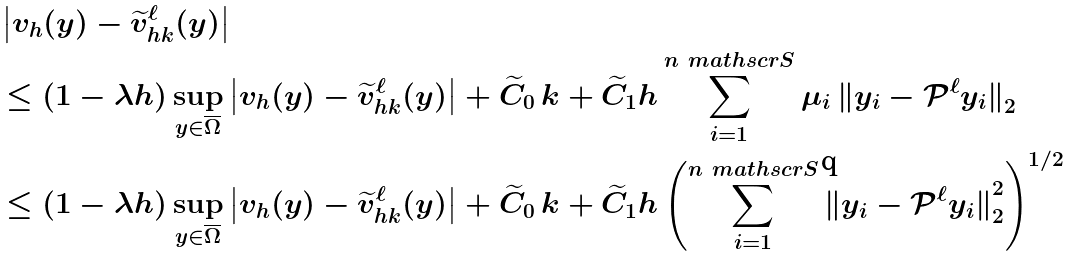Convert formula to latex. <formula><loc_0><loc_0><loc_500><loc_500>& \left | v _ { h } ( y ) - \widetilde { v } _ { h k } ^ { \ell } ( y ) \right | \\ & \leq ( 1 - \lambda h ) \sup _ { y \in \overline { \Omega } } \left | v _ { h } ( y ) - \widetilde { v } _ { h k } ^ { \ell } ( y ) \right | + \widetilde { C } _ { 0 } \, k + \widetilde { C } _ { 1 } h \sum _ { i = 1 } ^ { n _ { \ } m a t h s c r S } \mu _ { i } \, { \| y _ { i } - \mathcal { P } ^ { \ell } y _ { i } \| } _ { 2 } \\ & \leq ( 1 - \lambda h ) \sup _ { y \in \overline { \Omega } } \left | v _ { h } ( y ) - \widetilde { v } _ { h k } ^ { \ell } ( y ) \right | + \widetilde { C } _ { 0 } \, k + \widetilde { C } _ { 1 } h \left ( \sum _ { i = 1 } ^ { n _ { \ } m a t h s c r S } { \| y _ { i } - \mathcal { P } ^ { \ell } y _ { i } \| } _ { 2 } ^ { 2 } \right ) ^ { 1 / 2 }</formula> 